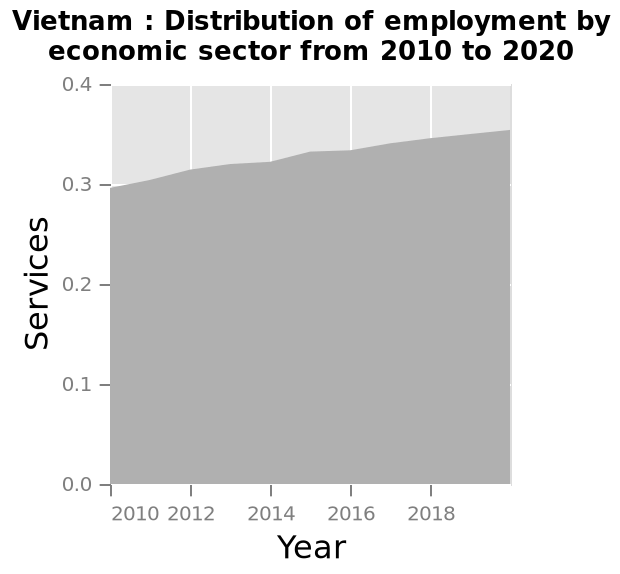<image>
What is the range of the y-axis? The range of the y-axis is 0.0 to 0.4. What is the title of the area chart? The title of the area chart is "Vietnam: Distribution of employment by economic sector from 2010 to 2020." What does the y-axis measure? The y-axis measures Services. What kind of trend does the graph in the figure show? The graph in the figure shows a steady upwards trend. 